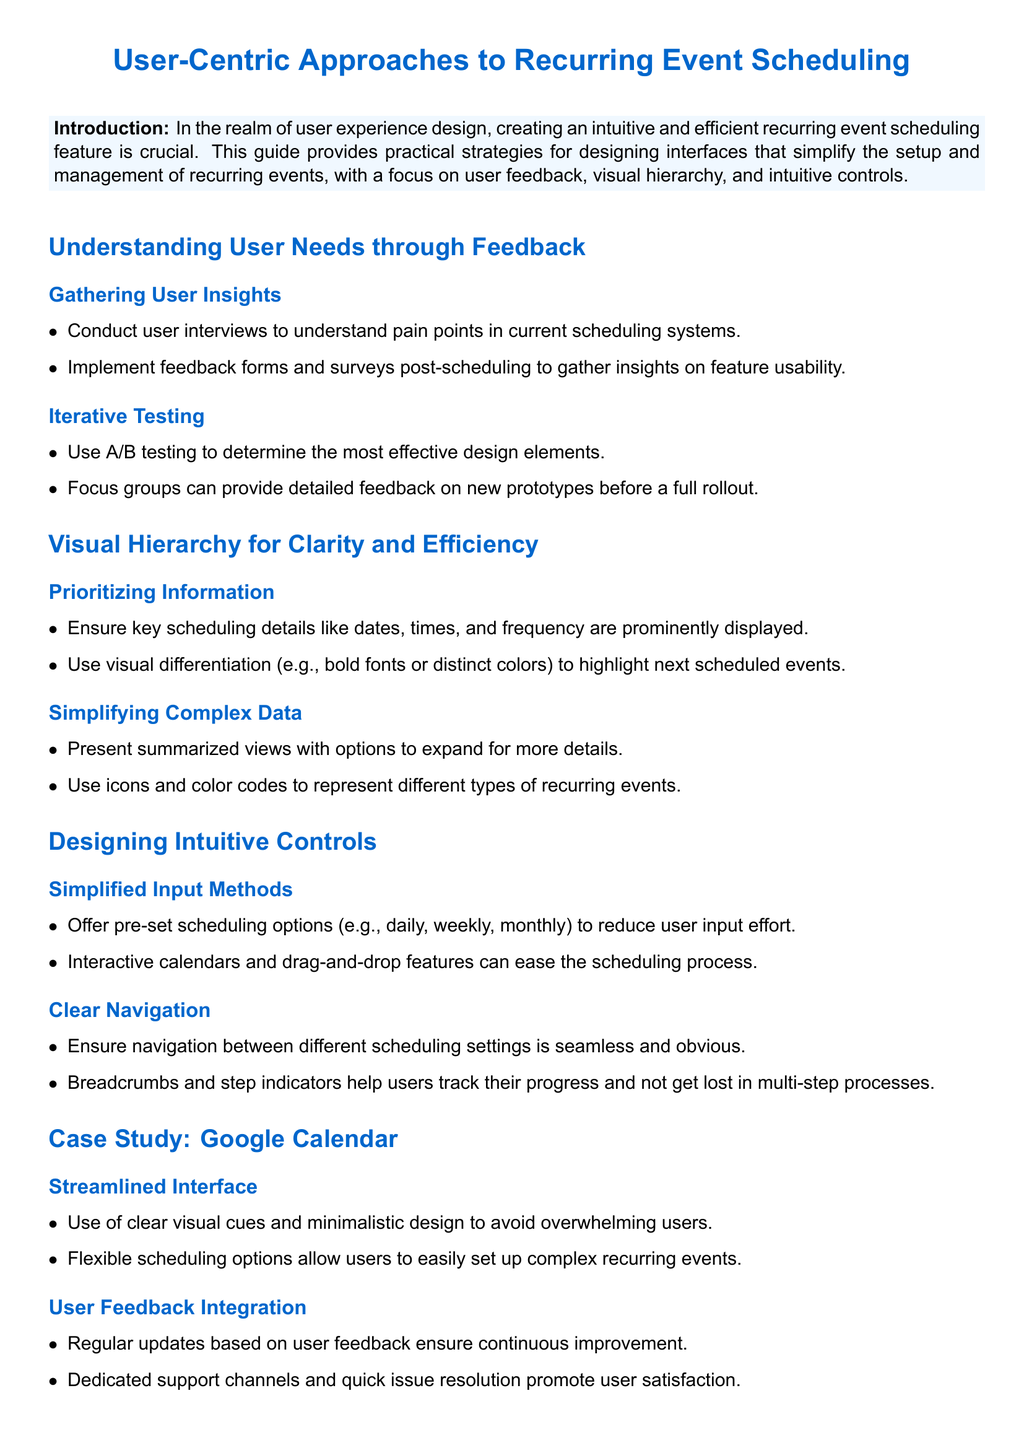What is the title of the document? The title is provided at the beginning of the document and highlights the main focus.
Answer: User-Centric Approaches to Recurring Event Scheduling How many subsections are under Understanding User Needs? The number of subsections is counted from the main section titled 'Understanding User Needs through Feedback.'
Answer: 2 What method is suggested for gathering user insights? The document provides specific methods for collecting user feedback to improve design.
Answer: Conduct user interviews Which design element helps highlight next scheduled events? The emphasis on certain visual traits aids in directing user attention.
Answer: Distinct colors What type of controls are recommended for simplifying input methods? The document suggests using specific features that require less user effort.
Answer: Pre-set scheduling options What is one key feature of Google Calendar's interface? The document outlines particular attributes of Google Calendar that enhance user experience.
Answer: Clear visual cues How often should updates be made based on user feedback? The document implies a continuous improvement approach, especially concerning user satisfaction.
Answer: Regularly What aids users in tracking their progress in multi-step processes? The document mentions tools that assist in user navigation during complex tasks.
Answer: Step indicators 